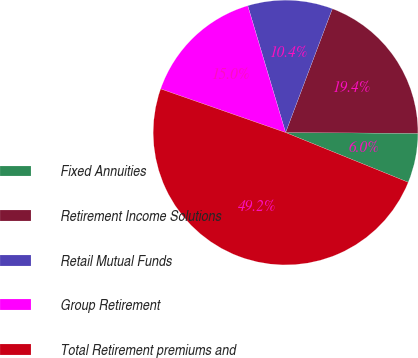Convert chart to OTSL. <chart><loc_0><loc_0><loc_500><loc_500><pie_chart><fcel>Fixed Annuities<fcel>Retirement Income Solutions<fcel>Retail Mutual Funds<fcel>Group Retirement<fcel>Total Retirement premiums and<nl><fcel>6.04%<fcel>19.35%<fcel>10.36%<fcel>15.04%<fcel>49.21%<nl></chart> 